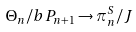Convert formula to latex. <formula><loc_0><loc_0><loc_500><loc_500>\Theta _ { n } / b P _ { n + 1 } \to \pi _ { n } ^ { S } / J</formula> 